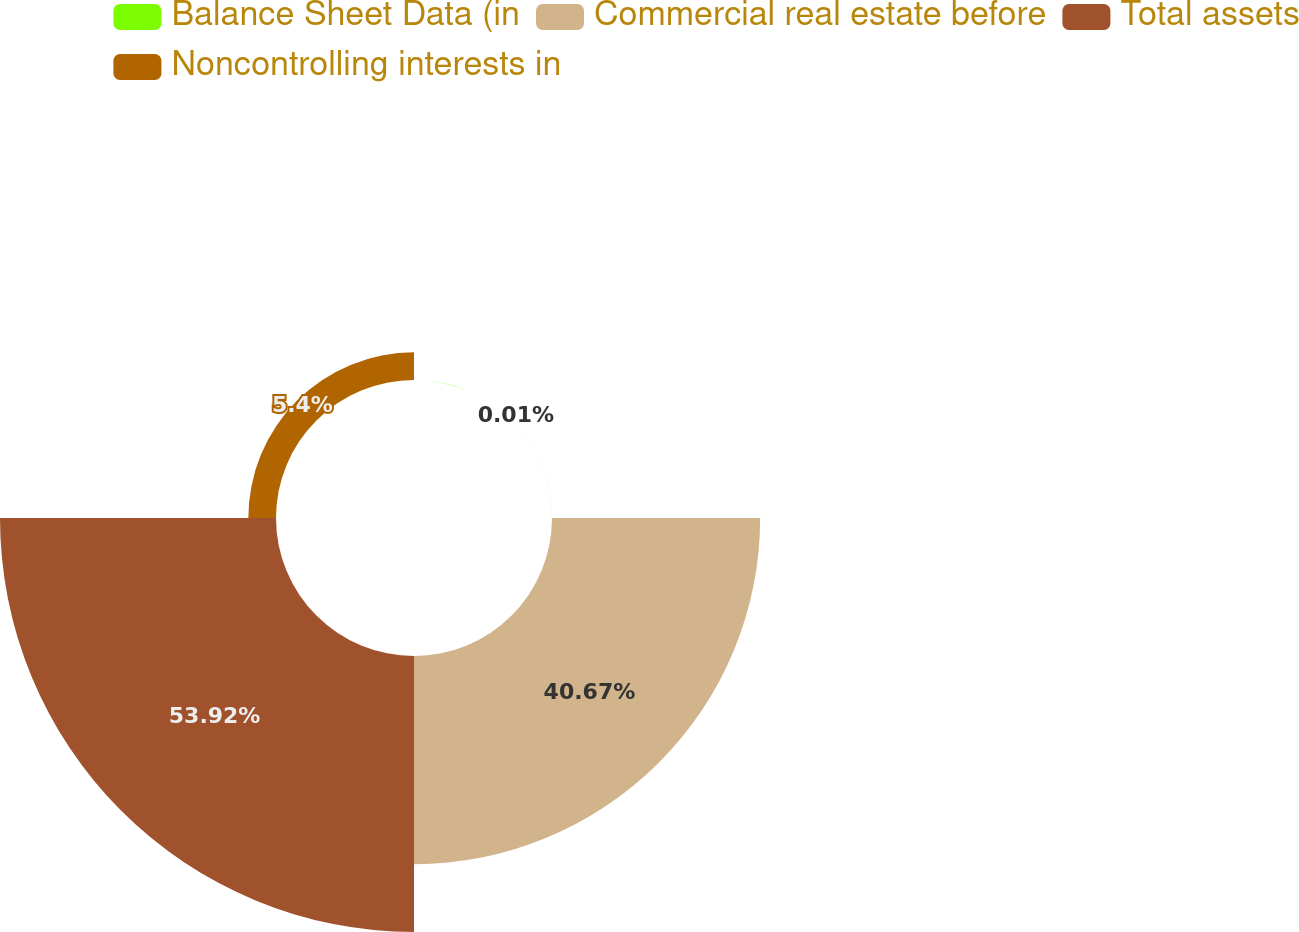<chart> <loc_0><loc_0><loc_500><loc_500><pie_chart><fcel>Balance Sheet Data (in<fcel>Commercial real estate before<fcel>Total assets<fcel>Noncontrolling interests in<nl><fcel>0.01%<fcel>40.67%<fcel>53.92%<fcel>5.4%<nl></chart> 